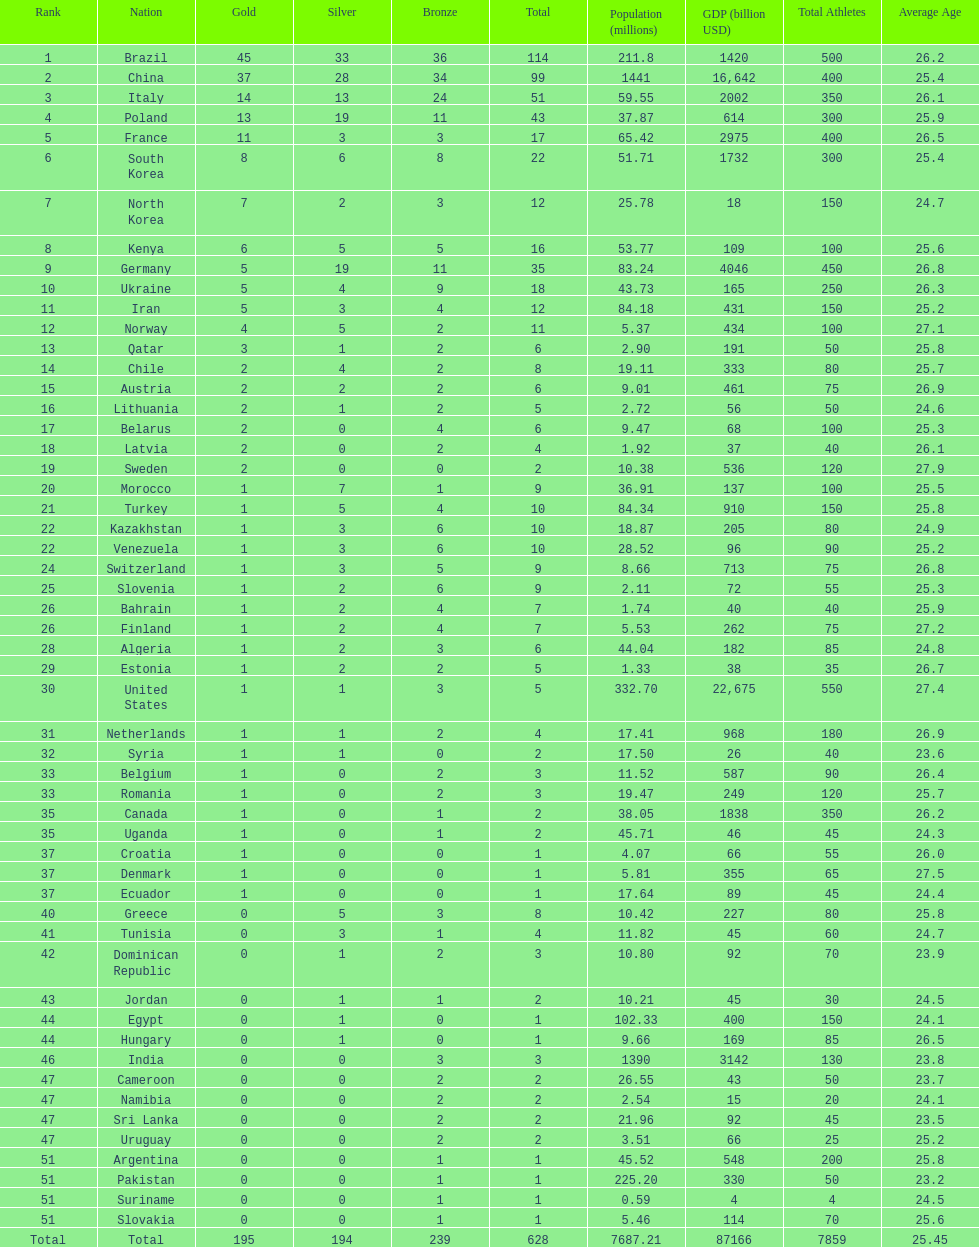How many more gold medals does china have over france? 26. 